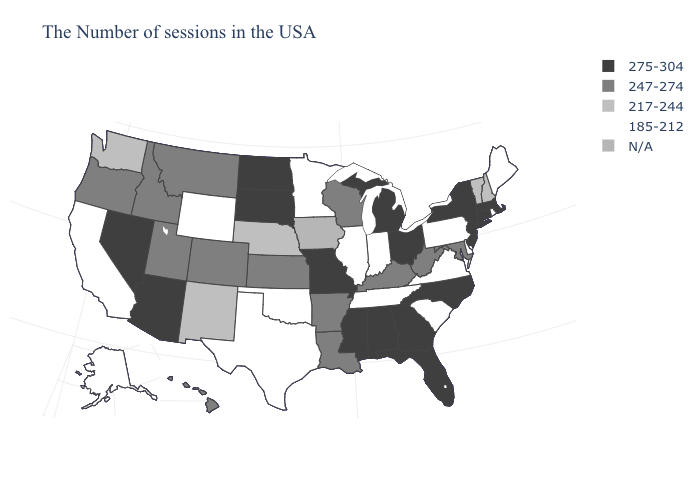What is the value of Wyoming?
Answer briefly. 185-212. Does Missouri have the highest value in the MidWest?
Be succinct. Yes. What is the lowest value in states that border Nebraska?
Keep it brief. 185-212. Does South Dakota have the highest value in the MidWest?
Short answer required. Yes. Does Rhode Island have the lowest value in the Northeast?
Keep it brief. Yes. Does Missouri have the lowest value in the MidWest?
Be succinct. No. Which states have the highest value in the USA?
Short answer required. Massachusetts, Connecticut, New York, New Jersey, North Carolina, Ohio, Florida, Georgia, Michigan, Alabama, Mississippi, Missouri, South Dakota, North Dakota, Arizona, Nevada. What is the value of Nebraska?
Quick response, please. 217-244. What is the value of Hawaii?
Quick response, please. 247-274. Name the states that have a value in the range 247-274?
Quick response, please. Maryland, West Virginia, Kentucky, Wisconsin, Louisiana, Arkansas, Kansas, Colorado, Utah, Montana, Idaho, Oregon, Hawaii. Which states hav the highest value in the Northeast?
Give a very brief answer. Massachusetts, Connecticut, New York, New Jersey. Name the states that have a value in the range 185-212?
Give a very brief answer. Maine, Rhode Island, Delaware, Pennsylvania, Virginia, South Carolina, Indiana, Tennessee, Illinois, Minnesota, Oklahoma, Texas, Wyoming, California, Alaska. Name the states that have a value in the range 217-244?
Quick response, please. New Hampshire, Vermont, Nebraska, New Mexico, Washington. Is the legend a continuous bar?
Quick response, please. No. 